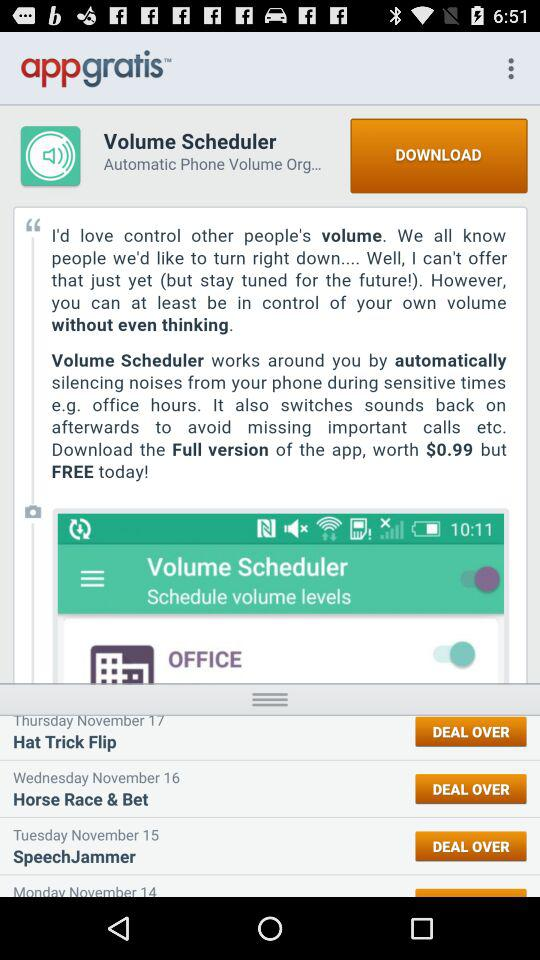What date is mentioned for SpeechJammer? The mentioned date for SpeechJammer is Tuesday, November 15. 